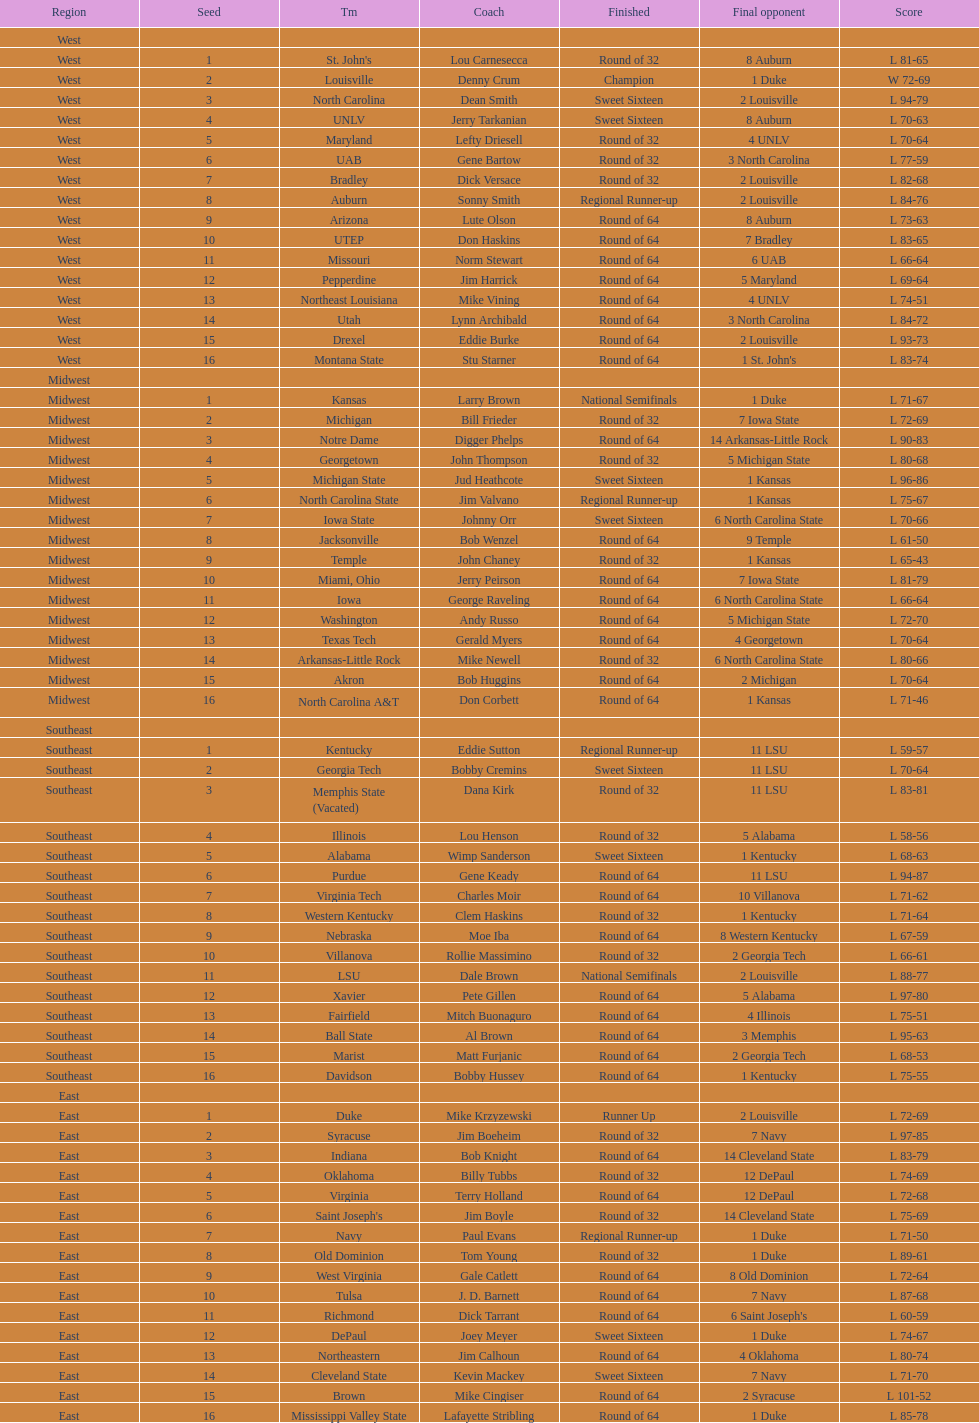Who is the only team from the east region to reach the final round? Duke. 